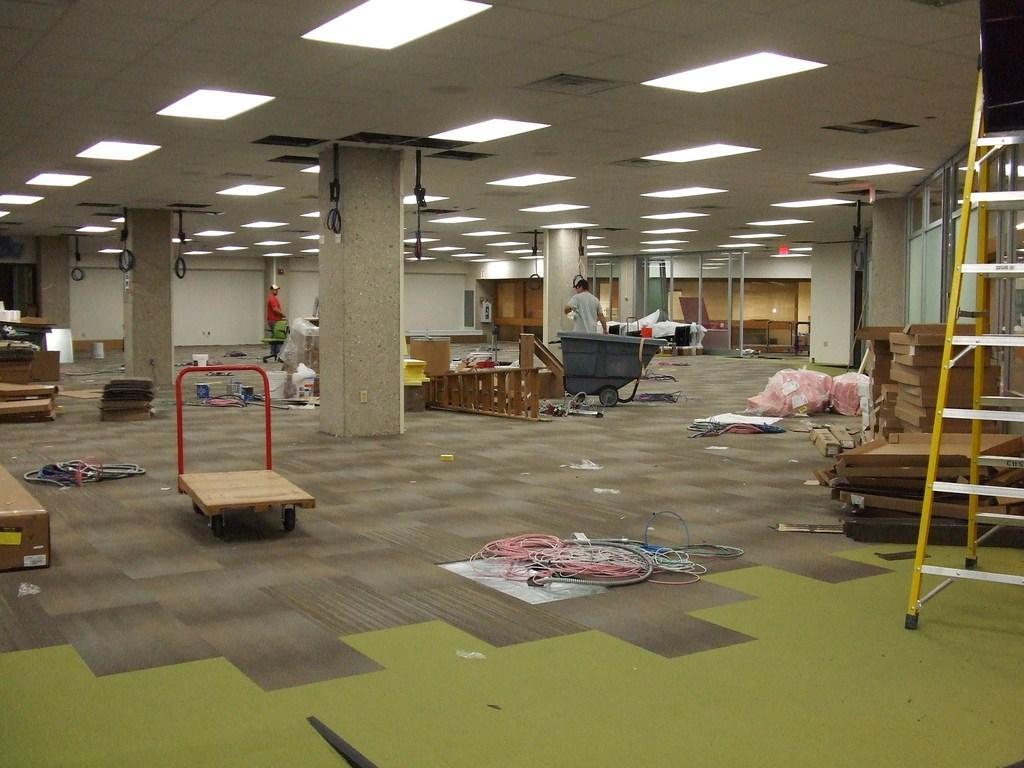How would you summarize this image in a sentence or two? In this image in the center there is a trolley and on the ground there are objects which are pink, white and blue in colour. In the background there are pillars and there are wires hanging and there are persons and there is a wall which is white in colour. On the right side there are wooden blocks and there is a ladder. 